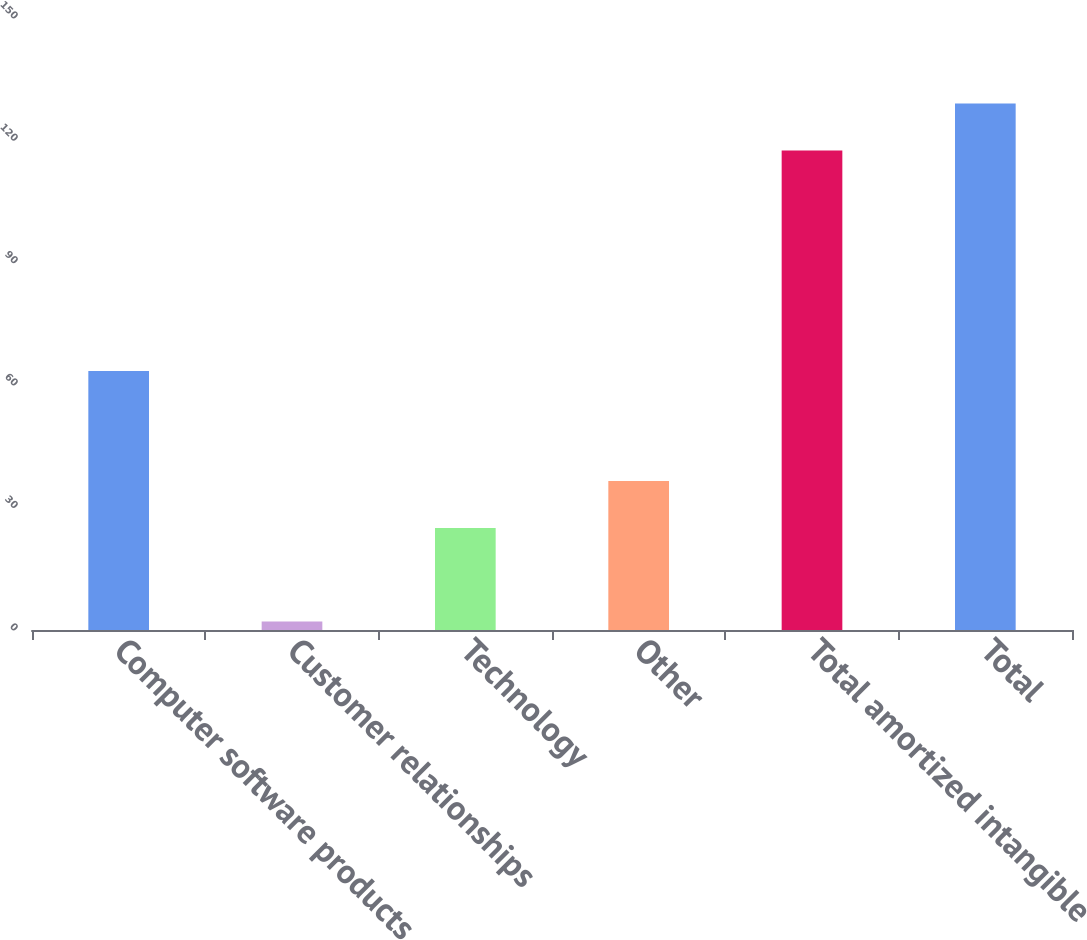Convert chart to OTSL. <chart><loc_0><loc_0><loc_500><loc_500><bar_chart><fcel>Computer software products<fcel>Customer relationships<fcel>Technology<fcel>Other<fcel>Total amortized intangible<fcel>Total<nl><fcel>63.5<fcel>2.1<fcel>25<fcel>36.54<fcel>117.5<fcel>129.04<nl></chart> 